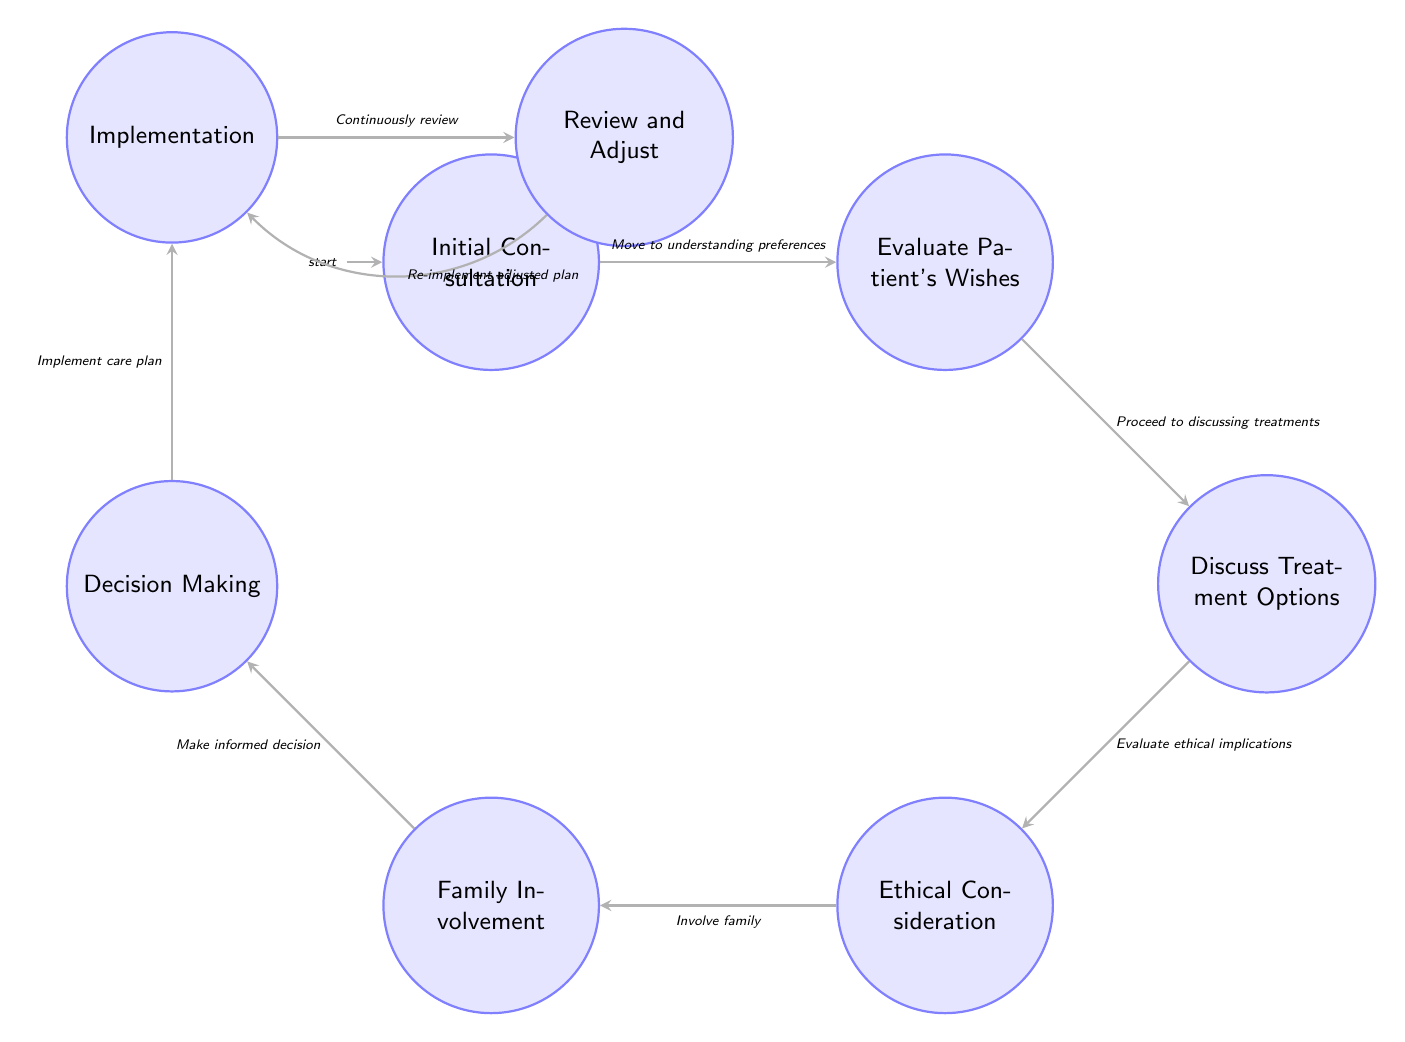What is the starting state in the diagram? The starting state, indicated as "Initial Consultation," shows where the process begins.
Answer: Initial Consultation How many states are in the diagram? Counting all the nodes listed in the diagram, there are a total of eight states.
Answer: 8 What is the last state in the process? The final state, presented in the flow of the diagram, is "Review and Adjust."
Answer: Review and Adjust Which state follows "Discuss Treatment Options"? Looking at the transitions, the state that follows "Discuss Treatment Options" is "Ethical Consideration."
Answer: Ethical Consideration What is the transition from "Implementation" to "Review and Adjust"? The transition indicates the process flow moving from "Implementation" to "Review and Adjust" is labeled as "Continuously review."
Answer: Continuously review What nodes involve family participation? The family involvement is indicated in the diagram at the nodes of "Family Involvement" and transitions to "Decision Making."
Answer: Family Involvement Which state focuses on patient preferences? The state that emphasizes understanding patient preferences is "Evaluate Patient's Wishes."
Answer: Evaluate Patient's Wishes What is the relationship between "Decision Making" and "Implementation"? There is a direct transition from "Decision Making" to "Implementation," suggesting that the decision impacts the implementation directly.
Answer: Implement care plan Which ethical principle is considered in the state "Ethical Consideration"? The state "Ethical Consideration" reflects on multiple ethical principles, specifically autonomy, beneficence, non-maleficence, and justice.
Answer: Autonomy, beneficence, non-maleficence, justice What is the purpose of "Review and Adjust"? The purpose labeled for "Review and Adjust" is to monitor the patient's response and make necessary adjustments to care.
Answer: Monitor patient’s response and adjust care plan as necessary 